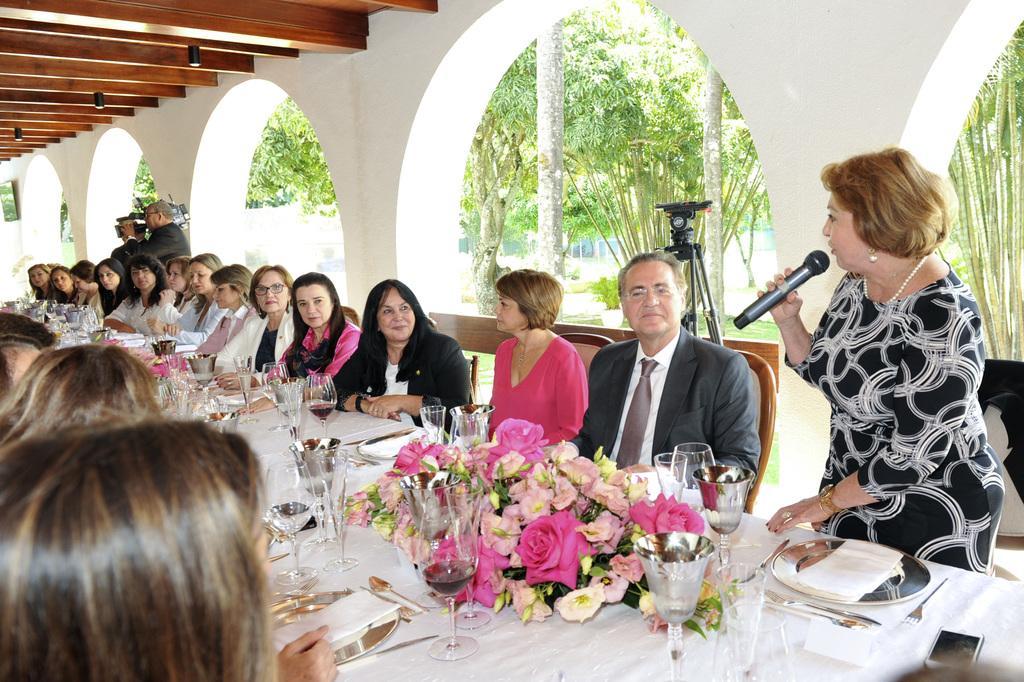In one or two sentences, can you explain what this image depicts? In this image there are group of people who are sitting on a chair. On the right side there is one woman who is standing and she is holding a mike and she is talking. On the left side there is one man who is standing and he is holding a camera, on the top there are wooden sticks and in the middle there is a wall and on the background there are some trees and in the center there is a table on the table there are some plates, tissue papers, glasses, and spoons and one flower bouquet is there on the table. 